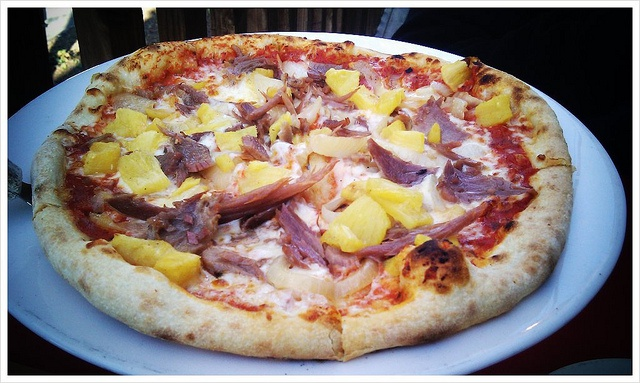Describe the objects in this image and their specific colors. I can see a pizza in lightgray, brown, darkgray, and tan tones in this image. 